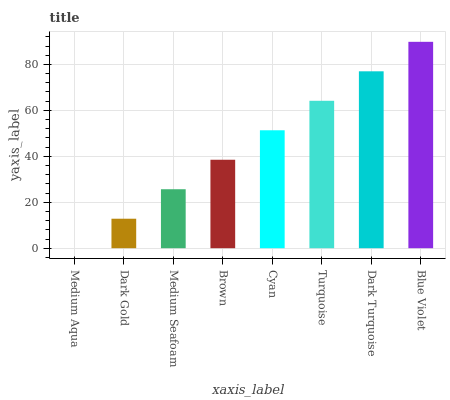Is Medium Aqua the minimum?
Answer yes or no. Yes. Is Blue Violet the maximum?
Answer yes or no. Yes. Is Dark Gold the minimum?
Answer yes or no. No. Is Dark Gold the maximum?
Answer yes or no. No. Is Dark Gold greater than Medium Aqua?
Answer yes or no. Yes. Is Medium Aqua less than Dark Gold?
Answer yes or no. Yes. Is Medium Aqua greater than Dark Gold?
Answer yes or no. No. Is Dark Gold less than Medium Aqua?
Answer yes or no. No. Is Cyan the high median?
Answer yes or no. Yes. Is Brown the low median?
Answer yes or no. Yes. Is Dark Turquoise the high median?
Answer yes or no. No. Is Medium Aqua the low median?
Answer yes or no. No. 